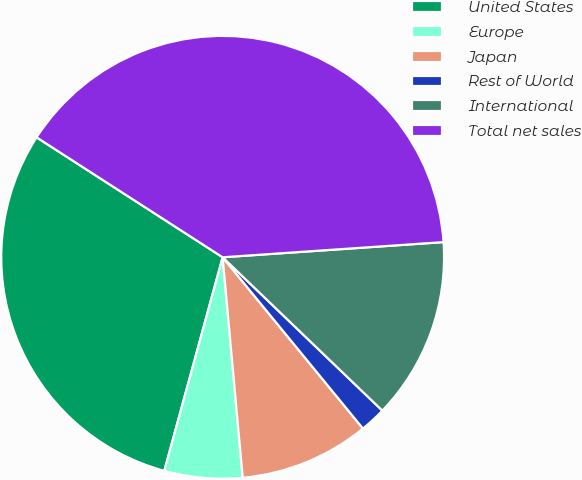<chart> <loc_0><loc_0><loc_500><loc_500><pie_chart><fcel>United States<fcel>Europe<fcel>Japan<fcel>Rest of World<fcel>International<fcel>Total net sales<nl><fcel>29.87%<fcel>5.69%<fcel>9.48%<fcel>1.9%<fcel>13.27%<fcel>39.8%<nl></chart> 